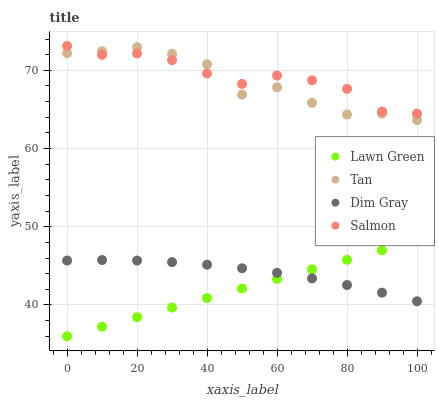Does Lawn Green have the minimum area under the curve?
Answer yes or no. Yes. Does Salmon have the maximum area under the curve?
Answer yes or no. Yes. Does Tan have the minimum area under the curve?
Answer yes or no. No. Does Tan have the maximum area under the curve?
Answer yes or no. No. Is Lawn Green the smoothest?
Answer yes or no. Yes. Is Tan the roughest?
Answer yes or no. Yes. Is Dim Gray the smoothest?
Answer yes or no. No. Is Dim Gray the roughest?
Answer yes or no. No. Does Lawn Green have the lowest value?
Answer yes or no. Yes. Does Tan have the lowest value?
Answer yes or no. No. Does Salmon have the highest value?
Answer yes or no. Yes. Does Tan have the highest value?
Answer yes or no. No. Is Lawn Green less than Tan?
Answer yes or no. Yes. Is Tan greater than Lawn Green?
Answer yes or no. Yes. Does Tan intersect Salmon?
Answer yes or no. Yes. Is Tan less than Salmon?
Answer yes or no. No. Is Tan greater than Salmon?
Answer yes or no. No. Does Lawn Green intersect Tan?
Answer yes or no. No. 